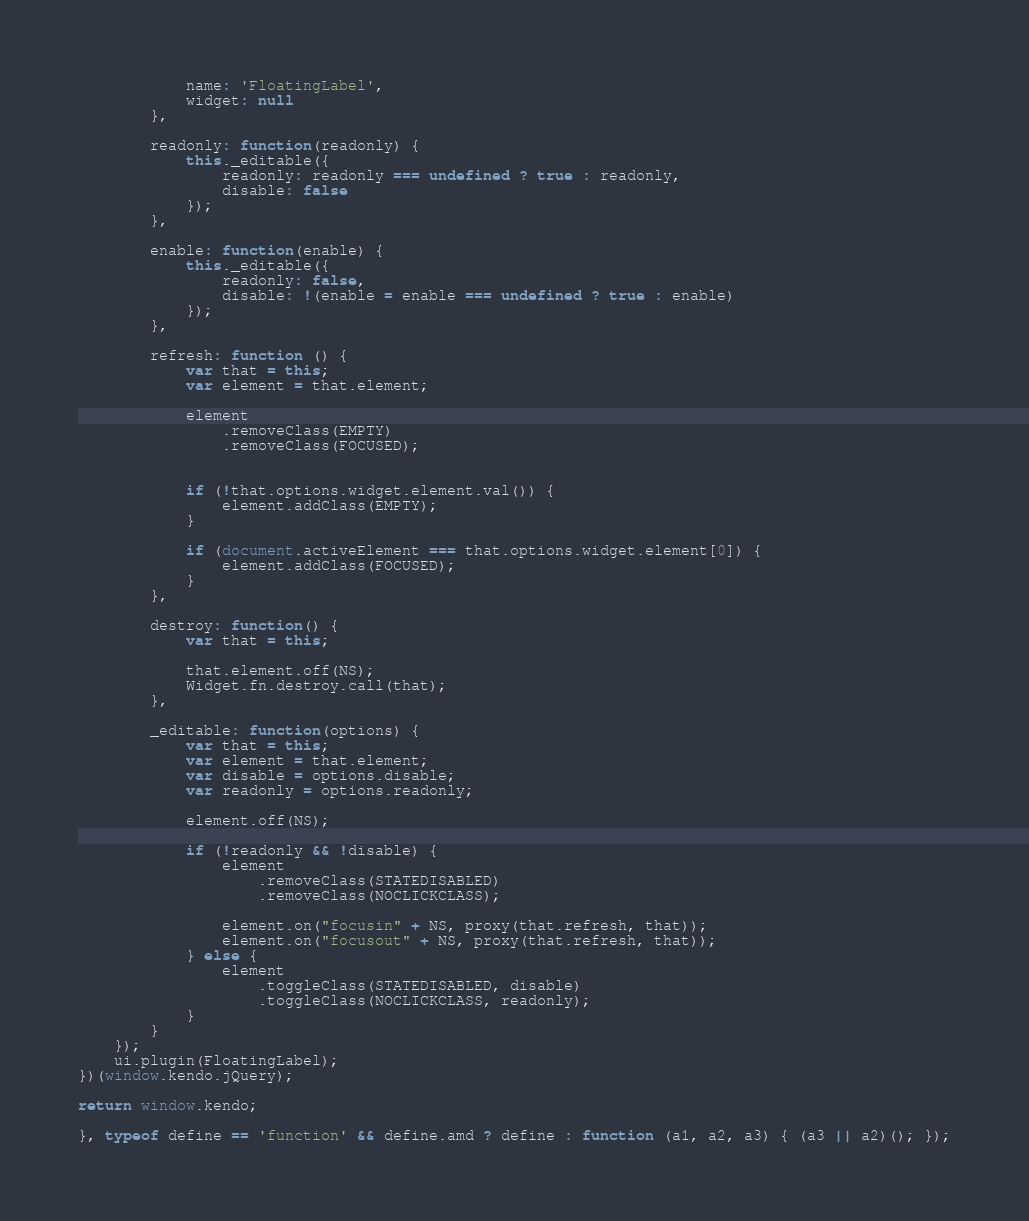Convert code to text. <code><loc_0><loc_0><loc_500><loc_500><_JavaScript_>            name: 'FloatingLabel',
            widget: null
        },

        readonly: function(readonly) {
            this._editable({
                readonly: readonly === undefined ? true : readonly,
                disable: false
            });
        },

        enable: function(enable) {
            this._editable({
                readonly: false,
                disable: !(enable = enable === undefined ? true : enable)
            });
        },

        refresh: function () {
            var that = this;
            var element = that.element;

            element
                .removeClass(EMPTY)
                .removeClass(FOCUSED);


            if (!that.options.widget.element.val()) {
                element.addClass(EMPTY);
            }

            if (document.activeElement === that.options.widget.element[0]) {
                element.addClass(FOCUSED);
            }
        },

        destroy: function() {
            var that = this;

            that.element.off(NS);
            Widget.fn.destroy.call(that);
        },

        _editable: function(options) {
            var that = this;
            var element = that.element;
            var disable = options.disable;
            var readonly = options.readonly;

            element.off(NS);

            if (!readonly && !disable) {
                element
                    .removeClass(STATEDISABLED)
                    .removeClass(NOCLICKCLASS);

                element.on("focusin" + NS, proxy(that.refresh, that));
                element.on("focusout" + NS, proxy(that.refresh, that));
            } else {
                element
                    .toggleClass(STATEDISABLED, disable)
                    .toggleClass(NOCLICKCLASS, readonly);
            }
        }
    });
    ui.plugin(FloatingLabel);
})(window.kendo.jQuery);

return window.kendo;

}, typeof define == 'function' && define.amd ? define : function (a1, a2, a3) { (a3 || a2)(); });
</code> 